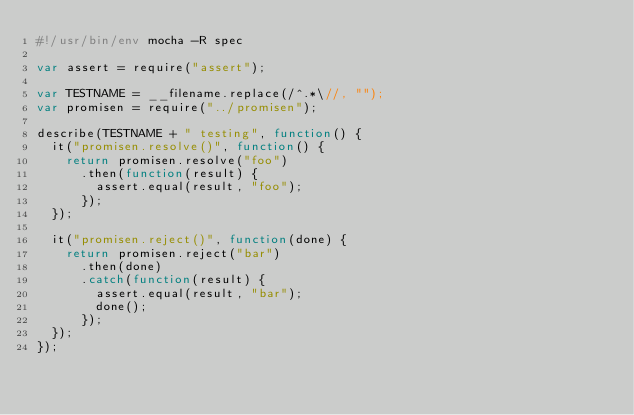<code> <loc_0><loc_0><loc_500><loc_500><_JavaScript_>#!/usr/bin/env mocha -R spec

var assert = require("assert");

var TESTNAME = __filename.replace(/^.*\//, "");
var promisen = require("../promisen");

describe(TESTNAME + " testing", function() {
  it("promisen.resolve()", function() {
    return promisen.resolve("foo")
      .then(function(result) {
        assert.equal(result, "foo");
      });
  });

  it("promisen.reject()", function(done) {
    return promisen.reject("bar")
      .then(done)
      .catch(function(result) {
        assert.equal(result, "bar");
        done();
      });
  });
});
</code> 